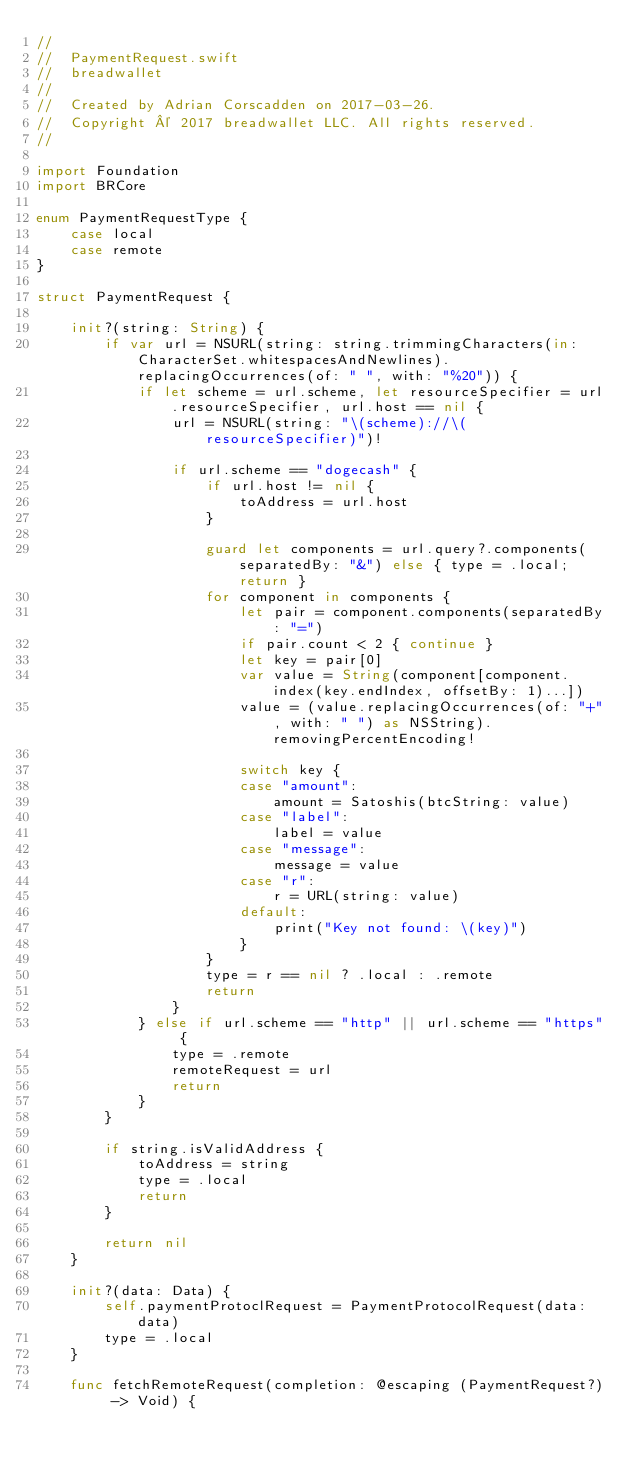<code> <loc_0><loc_0><loc_500><loc_500><_Swift_>//
//  PaymentRequest.swift
//  breadwallet
//
//  Created by Adrian Corscadden on 2017-03-26.
//  Copyright © 2017 breadwallet LLC. All rights reserved.
//

import Foundation
import BRCore

enum PaymentRequestType {
    case local
    case remote
}

struct PaymentRequest {

    init?(string: String) {
        if var url = NSURL(string: string.trimmingCharacters(in: CharacterSet.whitespacesAndNewlines).replacingOccurrences(of: " ", with: "%20")) {
            if let scheme = url.scheme, let resourceSpecifier = url.resourceSpecifier, url.host == nil {
                url = NSURL(string: "\(scheme)://\(resourceSpecifier)")!

                if url.scheme == "dogecash" {
                    if url.host != nil {
                        toAddress = url.host
                    }

                    guard let components = url.query?.components(separatedBy: "&") else { type = .local; return }
                    for component in components {
                        let pair = component.components(separatedBy: "=")
                        if pair.count < 2 { continue }
                        let key = pair[0]
                        var value = String(component[component.index(key.endIndex, offsetBy: 1)...])
                        value = (value.replacingOccurrences(of: "+", with: " ") as NSString).removingPercentEncoding!

                        switch key {
                        case "amount":
                            amount = Satoshis(btcString: value)
                        case "label":
                            label = value
                        case "message":
                            message = value
                        case "r":
                            r = URL(string: value)
                        default:
                            print("Key not found: \(key)")
                        }
                    }
                    type = r == nil ? .local : .remote
                    return
                }
            } else if url.scheme == "http" || url.scheme == "https" {
                type = .remote
                remoteRequest = url
                return
            }
        }

        if string.isValidAddress {
            toAddress = string
            type = .local
            return
        }

        return nil
    }

    init?(data: Data) {
        self.paymentProtoclRequest = PaymentProtocolRequest(data: data)
        type = .local
    }

    func fetchRemoteRequest(completion: @escaping (PaymentRequest?) -> Void) {
</code> 